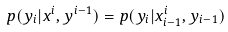Convert formula to latex. <formula><loc_0><loc_0><loc_500><loc_500>p ( y _ { i } | x ^ { i } , y ^ { i - 1 } ) = p ( y _ { i } | x _ { i - 1 } ^ { i } , y _ { i - 1 } )</formula> 